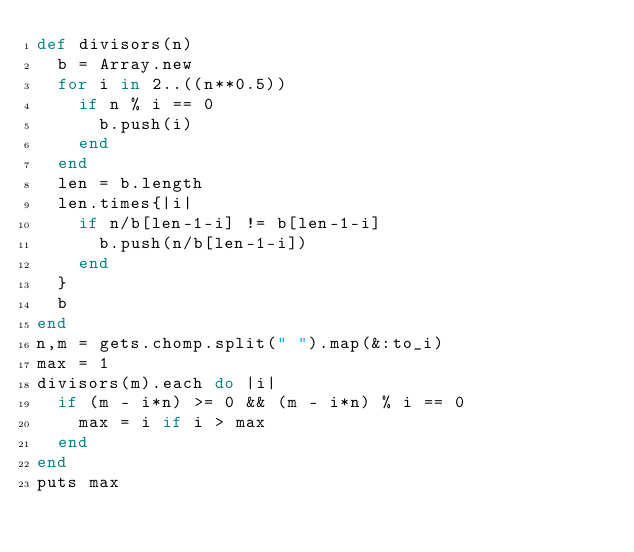Convert code to text. <code><loc_0><loc_0><loc_500><loc_500><_Ruby_>def divisors(n)
  b = Array.new
  for i in 2..((n**0.5))
    if n % i == 0
      b.push(i)
    end
  end
  len = b.length
  len.times{|i|
    if n/b[len-1-i] != b[len-1-i]
      b.push(n/b[len-1-i])
    end
  }
  b
end
n,m = gets.chomp.split(" ").map(&:to_i)
max = 1
divisors(m).each do |i|
  if (m - i*n) >= 0 && (m - i*n) % i == 0
    max = i if i > max
  end
end
puts max</code> 